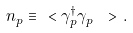Convert formula to latex. <formula><loc_0><loc_0><loc_500><loc_500>n _ { p } \equiv \ < \gamma _ { p } ^ { \dagger } \gamma _ { p } \ > \, .</formula> 